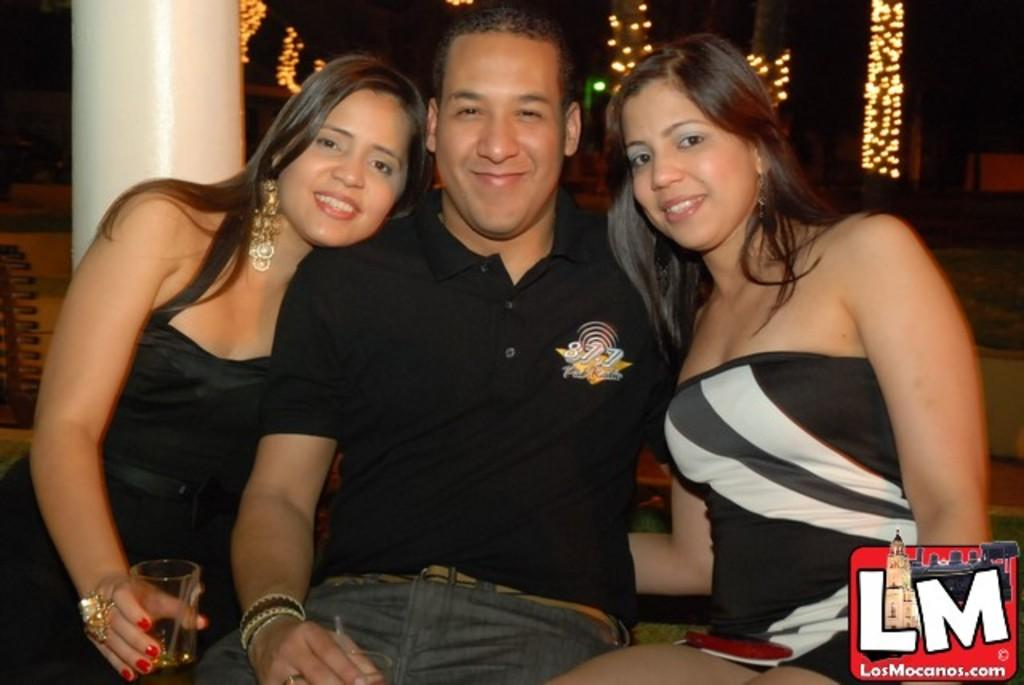How many people are in the image? There are three persons in the image. Can you describe the gender and attire of the people in the image? Two of them are girls, and one is a man. They are all wearing black dresses. What can be seen in the background of the image? There is a pillar in the background of the image. What is the woman sitting on the left holding? The woman sitting on the left is holding a glass. What type of cart can be seen in the image? There is no cart present in the image. What surprised the people in the image? The image does not depict any surprises or reactions, so it cannot be determined what might have surprised them. 